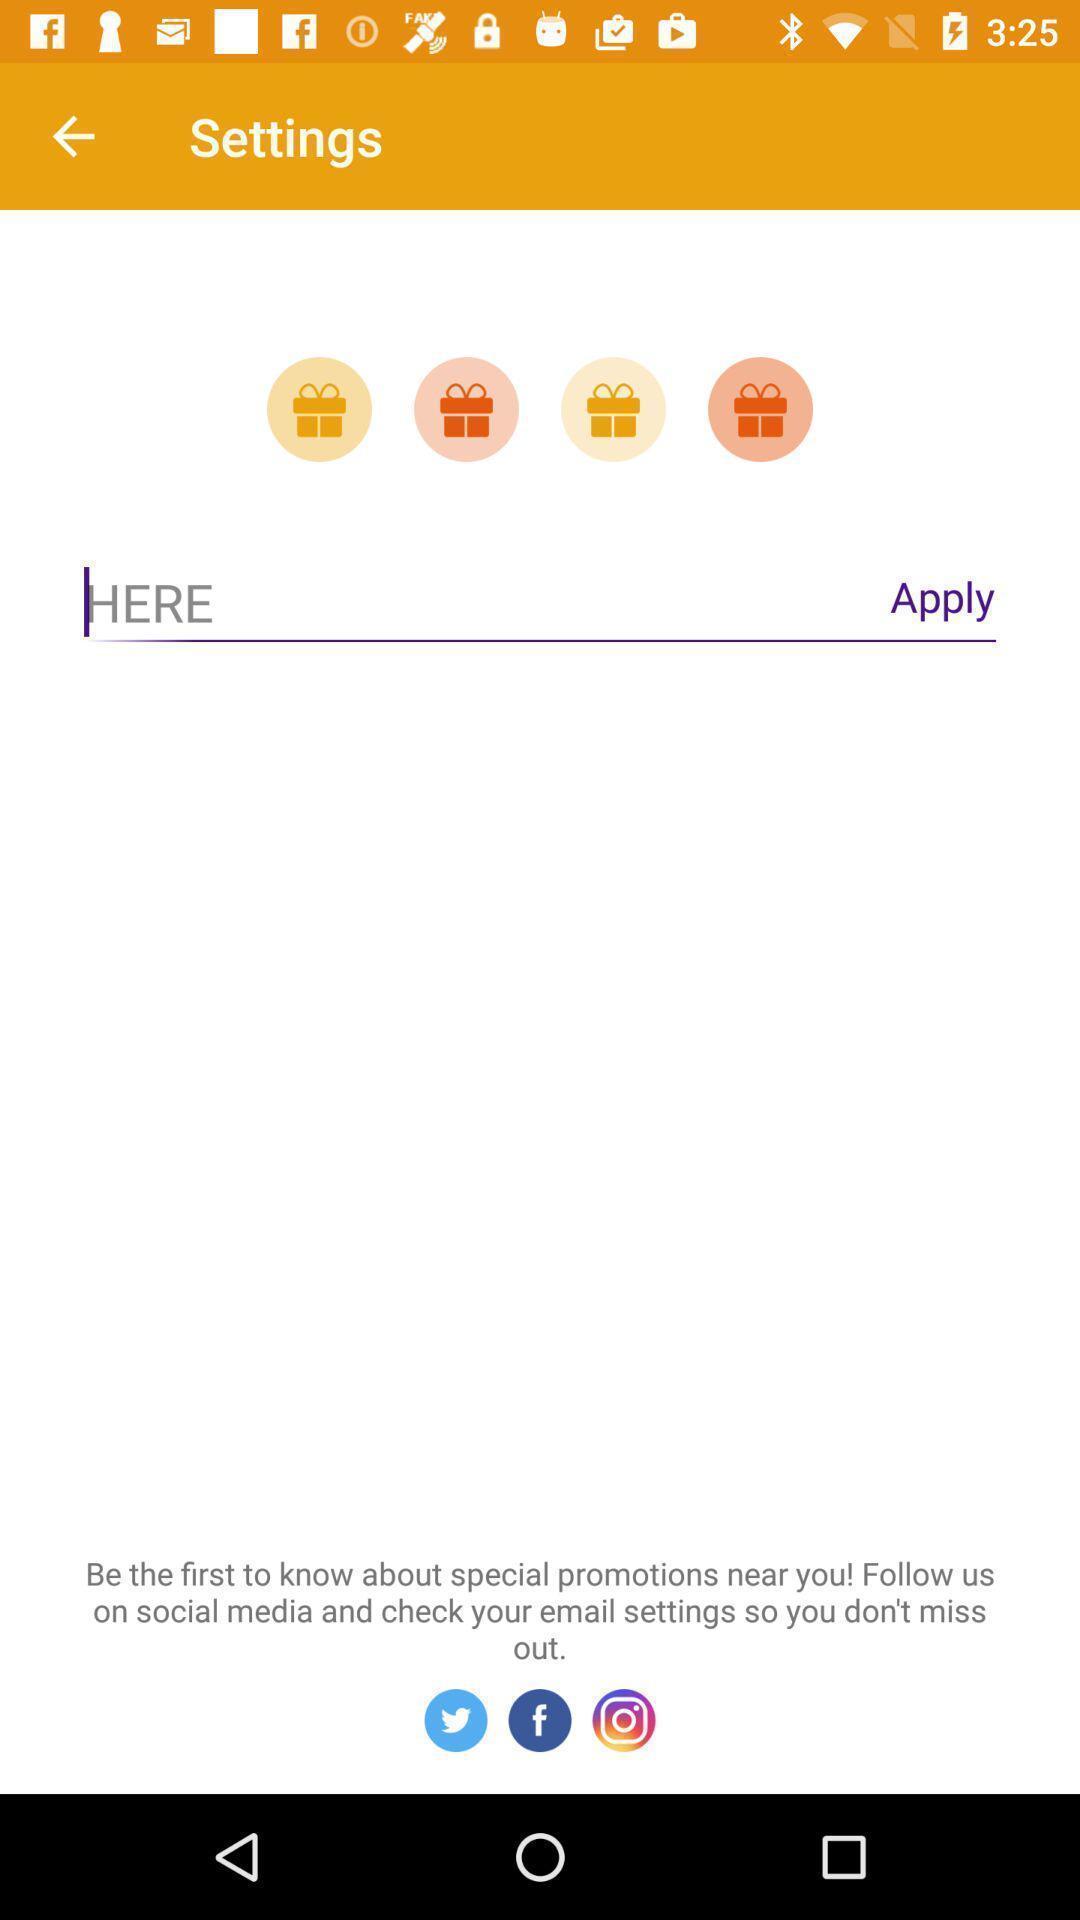Provide a detailed account of this screenshot. Page to get the food easily in a food app. 